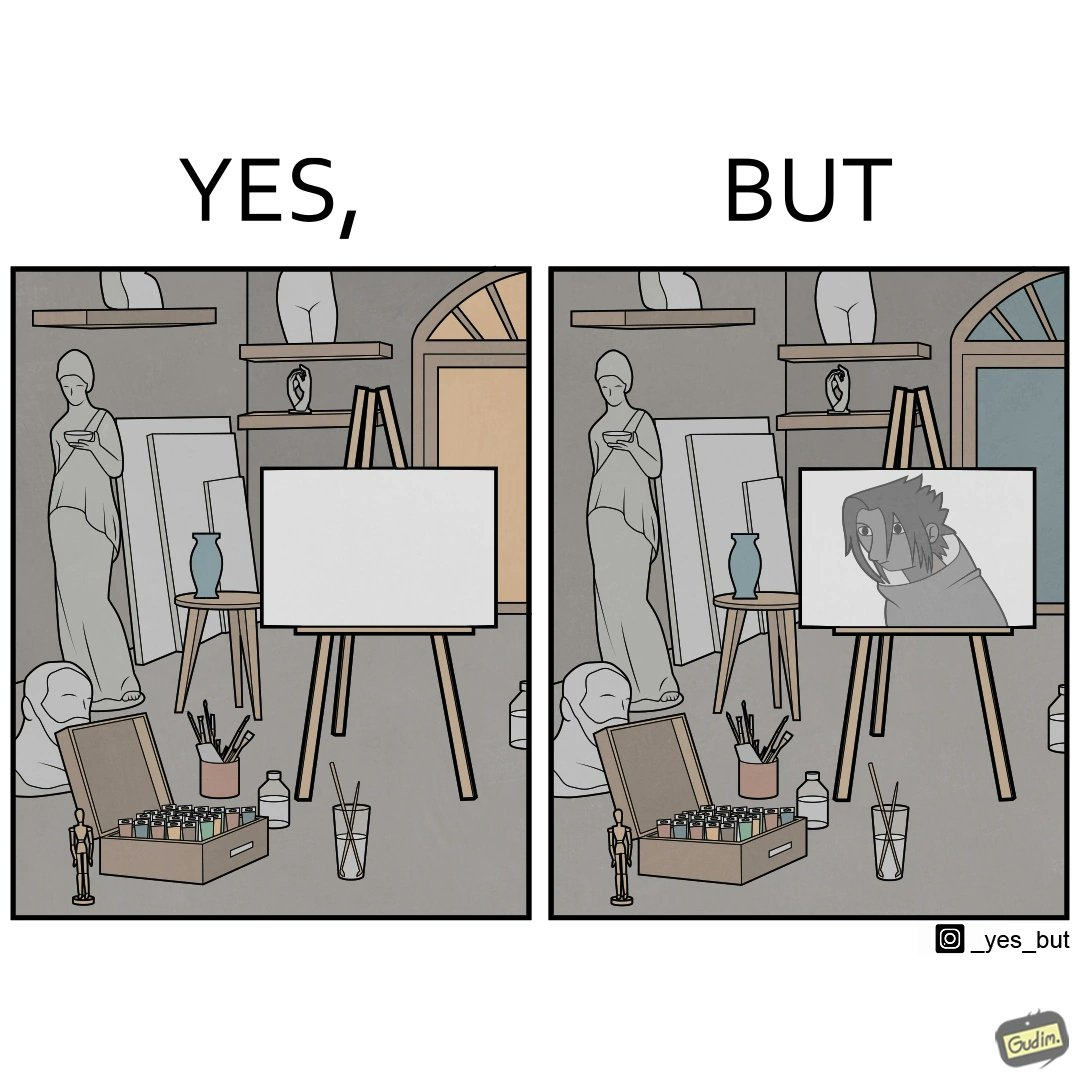What is shown in the left half versus the right half of this image? In the left part of the image: an art studio with a blank canvas. In the right part of the image: an art studio with a black and white painting on a canvas. 